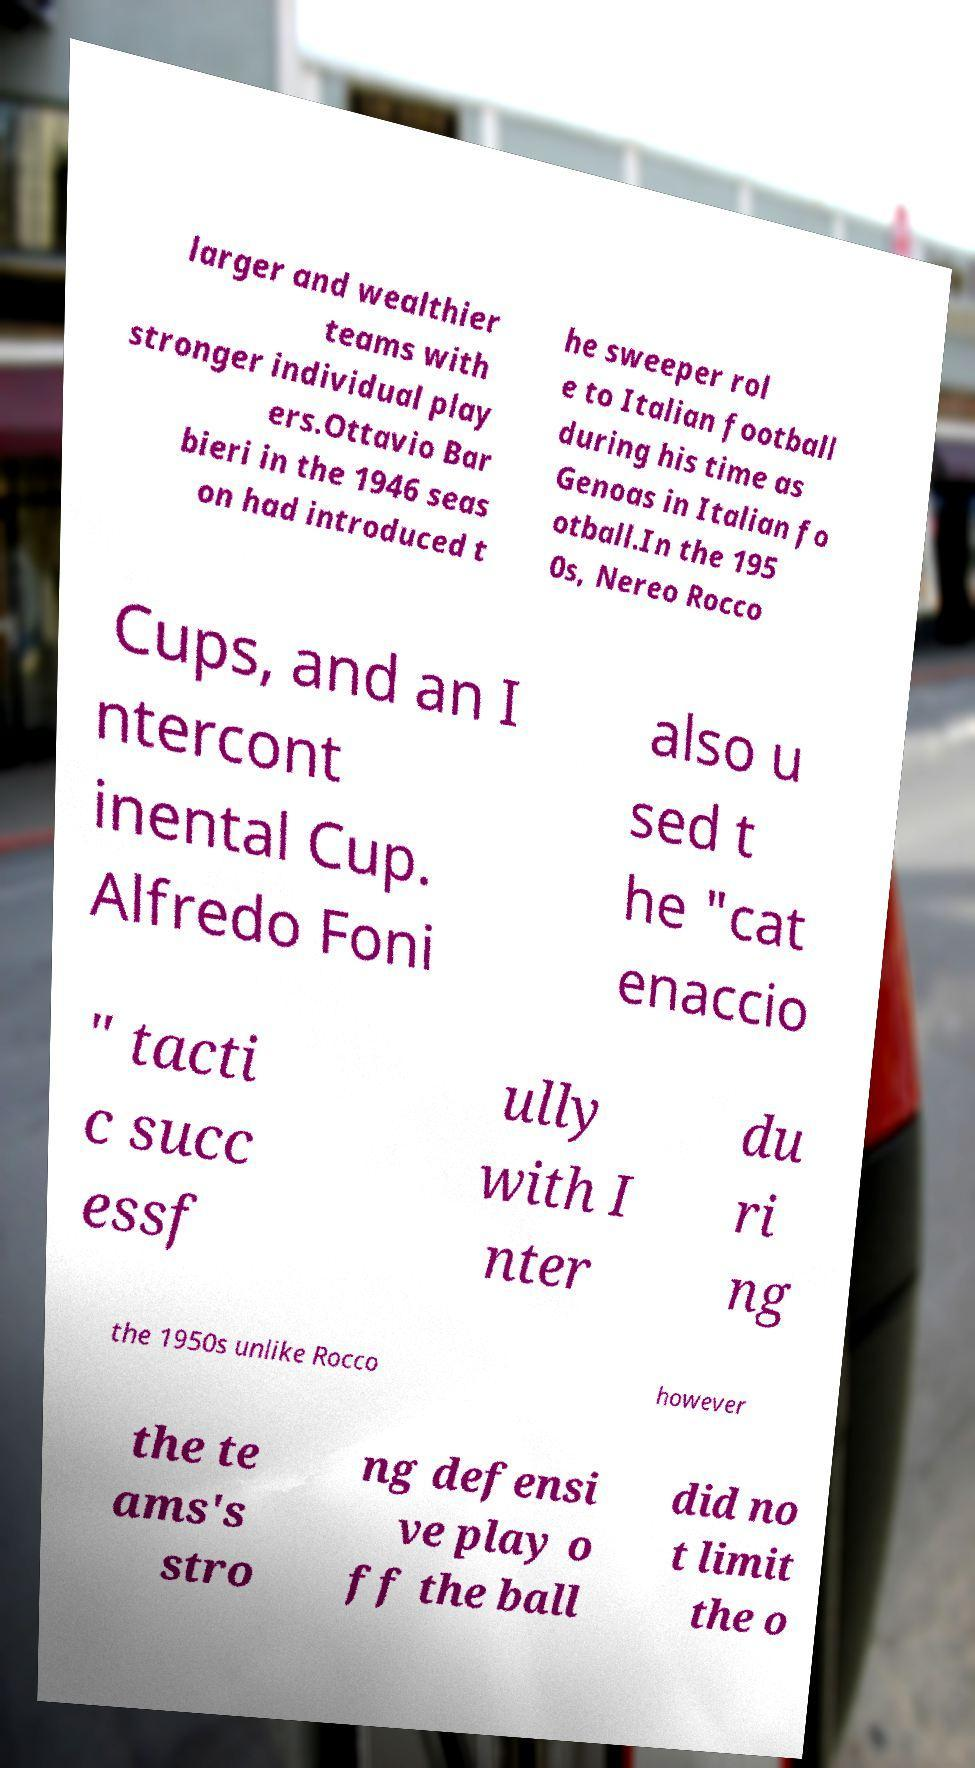Please read and relay the text visible in this image. What does it say? larger and wealthier teams with stronger individual play ers.Ottavio Bar bieri in the 1946 seas on had introduced t he sweeper rol e to Italian football during his time as Genoas in Italian fo otball.In the 195 0s, Nereo Rocco Cups, and an I ntercont inental Cup. Alfredo Foni also u sed t he "cat enaccio " tacti c succ essf ully with I nter du ri ng the 1950s unlike Rocco however the te ams's stro ng defensi ve play o ff the ball did no t limit the o 